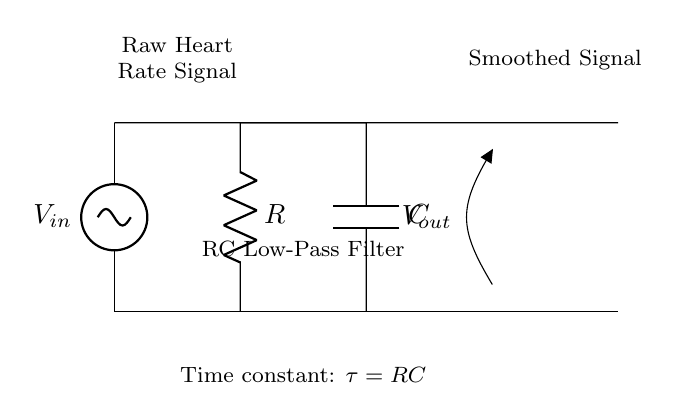What is the input voltage in this circuit? The input voltage is labeled as V_in, and it is the voltage source connected at the top of the circuit.
Answer: V_in What are the components used in the RC network? The components in the RC network are a resistor labeled R and a capacitor labeled C, which are connected in series to form a low-pass filter.
Answer: R and C What is the output signal labeled as? The output signal is labeled as V_out, which is the voltage across the capacitor, representing the smoothed heart rate signal.
Answer: V_out What is the time constant of this RC circuit? The time constant, denoted by τ, is calculated using the formula τ = RC, where R is the resistance and C is the capacitance.
Answer: τ = RC How does the RC network affect the heart rate signals? The RC network acts as a low-pass filter, allowing smoother signals to pass through while attenuating high-frequency noise, which is essential for accurate heart rate monitoring.
Answer: Smooths signals What is the configuration of the RC network in this circuit? The RC network is configured in a low-pass filter arrangement, where the output is taken across the capacitor, allowing low-frequency signals to be transmitted while filtering out higher frequencies.
Answer: Low-pass filter How is the output signal generated from the raw heart rate signal? The output signal is generated by the capacitive charging and discharging process, which smooths the rapid fluctuations of the raw heart rate signal into a steadier form.
Answer: Capacitive smoothing 